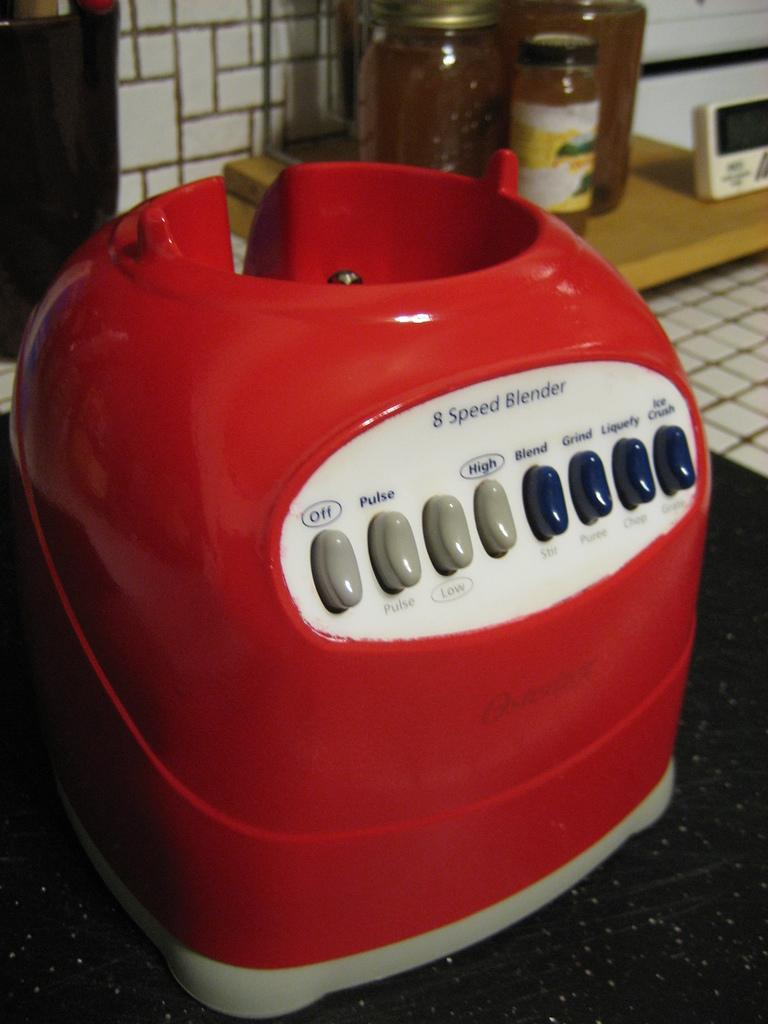Provide a one-sentence caption for the provided image. The red base to an 8 apeed blender. 